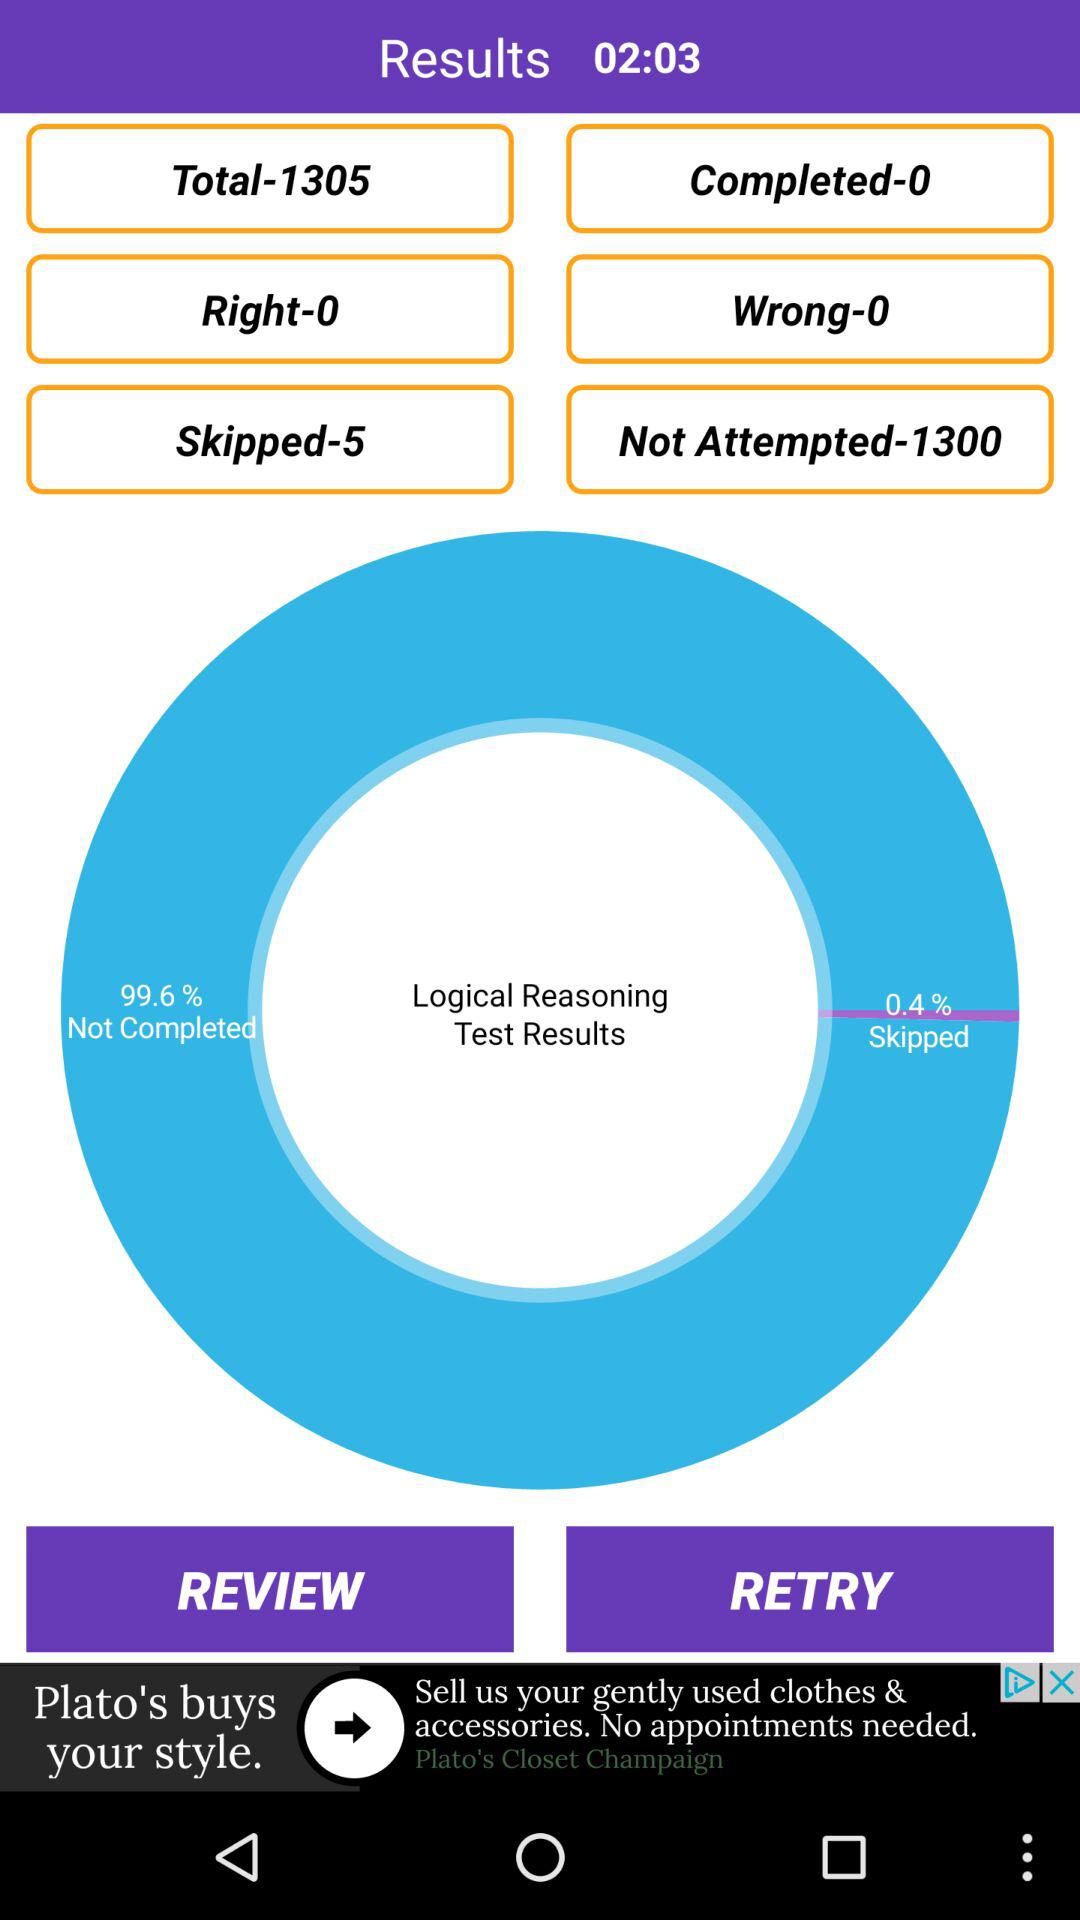What is the total question count? The total question count is 1305. 